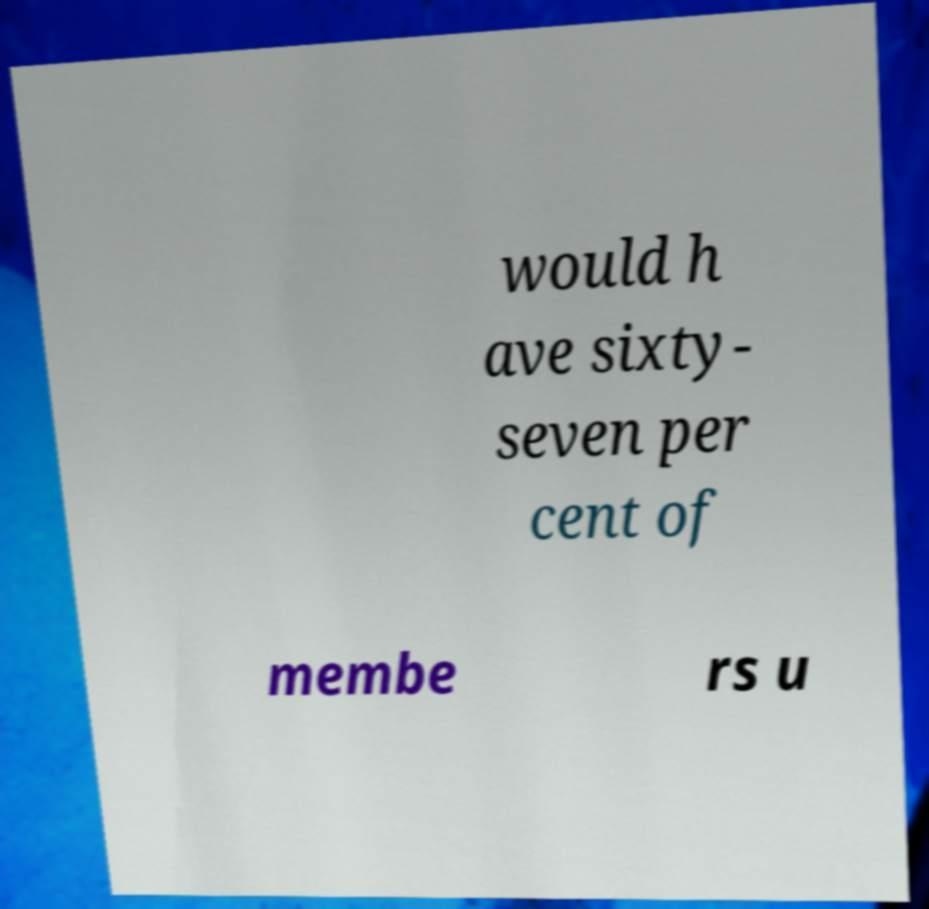Could you extract and type out the text from this image? would h ave sixty- seven per cent of membe rs u 